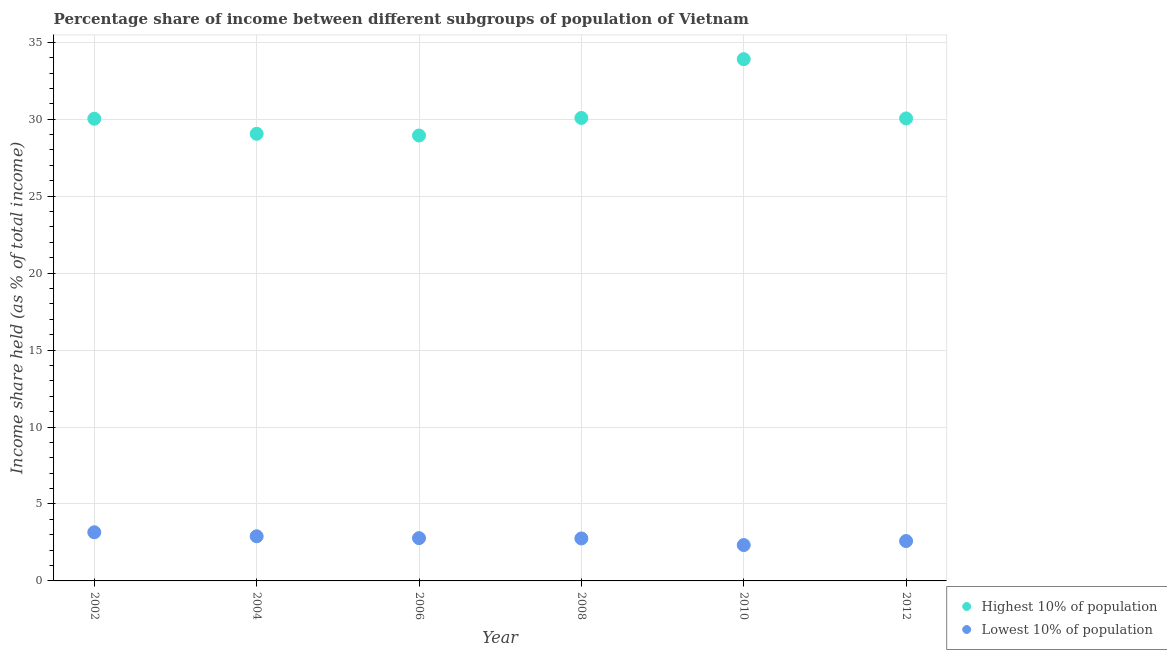How many different coloured dotlines are there?
Offer a very short reply. 2. What is the income share held by highest 10% of the population in 2002?
Give a very brief answer. 30.03. Across all years, what is the maximum income share held by lowest 10% of the population?
Ensure brevity in your answer.  3.16. Across all years, what is the minimum income share held by lowest 10% of the population?
Offer a very short reply. 2.33. In which year was the income share held by highest 10% of the population maximum?
Offer a very short reply. 2010. What is the total income share held by highest 10% of the population in the graph?
Offer a terse response. 182.05. What is the difference between the income share held by lowest 10% of the population in 2004 and that in 2010?
Your answer should be very brief. 0.57. What is the difference between the income share held by highest 10% of the population in 2006 and the income share held by lowest 10% of the population in 2012?
Offer a very short reply. 26.35. What is the average income share held by highest 10% of the population per year?
Provide a short and direct response. 30.34. In the year 2002, what is the difference between the income share held by lowest 10% of the population and income share held by highest 10% of the population?
Offer a terse response. -26.87. What is the ratio of the income share held by lowest 10% of the population in 2006 to that in 2012?
Your answer should be compact. 1.07. Is the income share held by highest 10% of the population in 2008 less than that in 2012?
Your answer should be compact. No. Is the difference between the income share held by lowest 10% of the population in 2002 and 2012 greater than the difference between the income share held by highest 10% of the population in 2002 and 2012?
Your response must be concise. Yes. What is the difference between the highest and the second highest income share held by lowest 10% of the population?
Your answer should be very brief. 0.26. What is the difference between the highest and the lowest income share held by highest 10% of the population?
Provide a short and direct response. 4.96. In how many years, is the income share held by highest 10% of the population greater than the average income share held by highest 10% of the population taken over all years?
Your answer should be very brief. 1. Does the income share held by lowest 10% of the population monotonically increase over the years?
Your answer should be compact. No. How many years are there in the graph?
Provide a short and direct response. 6. Are the values on the major ticks of Y-axis written in scientific E-notation?
Make the answer very short. No. Does the graph contain any zero values?
Provide a short and direct response. No. Does the graph contain grids?
Keep it short and to the point. Yes. How are the legend labels stacked?
Ensure brevity in your answer.  Vertical. What is the title of the graph?
Offer a very short reply. Percentage share of income between different subgroups of population of Vietnam. Does "Forest" appear as one of the legend labels in the graph?
Your response must be concise. No. What is the label or title of the Y-axis?
Provide a succinct answer. Income share held (as % of total income). What is the Income share held (as % of total income) of Highest 10% of population in 2002?
Make the answer very short. 30.03. What is the Income share held (as % of total income) of Lowest 10% of population in 2002?
Give a very brief answer. 3.16. What is the Income share held (as % of total income) in Highest 10% of population in 2004?
Provide a short and direct response. 29.05. What is the Income share held (as % of total income) of Lowest 10% of population in 2004?
Provide a succinct answer. 2.9. What is the Income share held (as % of total income) of Highest 10% of population in 2006?
Ensure brevity in your answer.  28.94. What is the Income share held (as % of total income) of Lowest 10% of population in 2006?
Provide a succinct answer. 2.78. What is the Income share held (as % of total income) in Highest 10% of population in 2008?
Offer a terse response. 30.08. What is the Income share held (as % of total income) of Lowest 10% of population in 2008?
Give a very brief answer. 2.76. What is the Income share held (as % of total income) in Highest 10% of population in 2010?
Provide a short and direct response. 33.9. What is the Income share held (as % of total income) in Lowest 10% of population in 2010?
Your answer should be compact. 2.33. What is the Income share held (as % of total income) of Highest 10% of population in 2012?
Ensure brevity in your answer.  30.05. What is the Income share held (as % of total income) in Lowest 10% of population in 2012?
Offer a terse response. 2.59. Across all years, what is the maximum Income share held (as % of total income) in Highest 10% of population?
Give a very brief answer. 33.9. Across all years, what is the maximum Income share held (as % of total income) in Lowest 10% of population?
Provide a short and direct response. 3.16. Across all years, what is the minimum Income share held (as % of total income) in Highest 10% of population?
Give a very brief answer. 28.94. Across all years, what is the minimum Income share held (as % of total income) of Lowest 10% of population?
Make the answer very short. 2.33. What is the total Income share held (as % of total income) of Highest 10% of population in the graph?
Provide a short and direct response. 182.05. What is the total Income share held (as % of total income) of Lowest 10% of population in the graph?
Give a very brief answer. 16.52. What is the difference between the Income share held (as % of total income) in Lowest 10% of population in 2002 and that in 2004?
Provide a succinct answer. 0.26. What is the difference between the Income share held (as % of total income) in Highest 10% of population in 2002 and that in 2006?
Your answer should be very brief. 1.09. What is the difference between the Income share held (as % of total income) of Lowest 10% of population in 2002 and that in 2006?
Provide a succinct answer. 0.38. What is the difference between the Income share held (as % of total income) of Highest 10% of population in 2002 and that in 2010?
Offer a very short reply. -3.87. What is the difference between the Income share held (as % of total income) of Lowest 10% of population in 2002 and that in 2010?
Your answer should be compact. 0.83. What is the difference between the Income share held (as % of total income) in Highest 10% of population in 2002 and that in 2012?
Ensure brevity in your answer.  -0.02. What is the difference between the Income share held (as % of total income) in Lowest 10% of population in 2002 and that in 2012?
Provide a short and direct response. 0.57. What is the difference between the Income share held (as % of total income) in Highest 10% of population in 2004 and that in 2006?
Offer a terse response. 0.11. What is the difference between the Income share held (as % of total income) in Lowest 10% of population in 2004 and that in 2006?
Offer a very short reply. 0.12. What is the difference between the Income share held (as % of total income) in Highest 10% of population in 2004 and that in 2008?
Your answer should be compact. -1.03. What is the difference between the Income share held (as % of total income) in Lowest 10% of population in 2004 and that in 2008?
Your response must be concise. 0.14. What is the difference between the Income share held (as % of total income) of Highest 10% of population in 2004 and that in 2010?
Your answer should be compact. -4.85. What is the difference between the Income share held (as % of total income) in Lowest 10% of population in 2004 and that in 2010?
Your answer should be very brief. 0.57. What is the difference between the Income share held (as % of total income) in Lowest 10% of population in 2004 and that in 2012?
Give a very brief answer. 0.31. What is the difference between the Income share held (as % of total income) in Highest 10% of population in 2006 and that in 2008?
Your response must be concise. -1.14. What is the difference between the Income share held (as % of total income) in Lowest 10% of population in 2006 and that in 2008?
Make the answer very short. 0.02. What is the difference between the Income share held (as % of total income) in Highest 10% of population in 2006 and that in 2010?
Make the answer very short. -4.96. What is the difference between the Income share held (as % of total income) in Lowest 10% of population in 2006 and that in 2010?
Provide a succinct answer. 0.45. What is the difference between the Income share held (as % of total income) in Highest 10% of population in 2006 and that in 2012?
Provide a short and direct response. -1.11. What is the difference between the Income share held (as % of total income) of Lowest 10% of population in 2006 and that in 2012?
Provide a succinct answer. 0.19. What is the difference between the Income share held (as % of total income) in Highest 10% of population in 2008 and that in 2010?
Give a very brief answer. -3.82. What is the difference between the Income share held (as % of total income) of Lowest 10% of population in 2008 and that in 2010?
Offer a terse response. 0.43. What is the difference between the Income share held (as % of total income) in Highest 10% of population in 2008 and that in 2012?
Your response must be concise. 0.03. What is the difference between the Income share held (as % of total income) of Lowest 10% of population in 2008 and that in 2012?
Your response must be concise. 0.17. What is the difference between the Income share held (as % of total income) of Highest 10% of population in 2010 and that in 2012?
Your answer should be very brief. 3.85. What is the difference between the Income share held (as % of total income) of Lowest 10% of population in 2010 and that in 2012?
Keep it short and to the point. -0.26. What is the difference between the Income share held (as % of total income) in Highest 10% of population in 2002 and the Income share held (as % of total income) in Lowest 10% of population in 2004?
Your answer should be very brief. 27.13. What is the difference between the Income share held (as % of total income) in Highest 10% of population in 2002 and the Income share held (as % of total income) in Lowest 10% of population in 2006?
Your answer should be very brief. 27.25. What is the difference between the Income share held (as % of total income) in Highest 10% of population in 2002 and the Income share held (as % of total income) in Lowest 10% of population in 2008?
Ensure brevity in your answer.  27.27. What is the difference between the Income share held (as % of total income) in Highest 10% of population in 2002 and the Income share held (as % of total income) in Lowest 10% of population in 2010?
Offer a very short reply. 27.7. What is the difference between the Income share held (as % of total income) in Highest 10% of population in 2002 and the Income share held (as % of total income) in Lowest 10% of population in 2012?
Offer a very short reply. 27.44. What is the difference between the Income share held (as % of total income) of Highest 10% of population in 2004 and the Income share held (as % of total income) of Lowest 10% of population in 2006?
Offer a terse response. 26.27. What is the difference between the Income share held (as % of total income) in Highest 10% of population in 2004 and the Income share held (as % of total income) in Lowest 10% of population in 2008?
Ensure brevity in your answer.  26.29. What is the difference between the Income share held (as % of total income) in Highest 10% of population in 2004 and the Income share held (as % of total income) in Lowest 10% of population in 2010?
Give a very brief answer. 26.72. What is the difference between the Income share held (as % of total income) of Highest 10% of population in 2004 and the Income share held (as % of total income) of Lowest 10% of population in 2012?
Your answer should be very brief. 26.46. What is the difference between the Income share held (as % of total income) in Highest 10% of population in 2006 and the Income share held (as % of total income) in Lowest 10% of population in 2008?
Your response must be concise. 26.18. What is the difference between the Income share held (as % of total income) of Highest 10% of population in 2006 and the Income share held (as % of total income) of Lowest 10% of population in 2010?
Offer a very short reply. 26.61. What is the difference between the Income share held (as % of total income) of Highest 10% of population in 2006 and the Income share held (as % of total income) of Lowest 10% of population in 2012?
Ensure brevity in your answer.  26.35. What is the difference between the Income share held (as % of total income) of Highest 10% of population in 2008 and the Income share held (as % of total income) of Lowest 10% of population in 2010?
Give a very brief answer. 27.75. What is the difference between the Income share held (as % of total income) in Highest 10% of population in 2008 and the Income share held (as % of total income) in Lowest 10% of population in 2012?
Ensure brevity in your answer.  27.49. What is the difference between the Income share held (as % of total income) in Highest 10% of population in 2010 and the Income share held (as % of total income) in Lowest 10% of population in 2012?
Your response must be concise. 31.31. What is the average Income share held (as % of total income) of Highest 10% of population per year?
Keep it short and to the point. 30.34. What is the average Income share held (as % of total income) of Lowest 10% of population per year?
Ensure brevity in your answer.  2.75. In the year 2002, what is the difference between the Income share held (as % of total income) in Highest 10% of population and Income share held (as % of total income) in Lowest 10% of population?
Offer a terse response. 26.87. In the year 2004, what is the difference between the Income share held (as % of total income) in Highest 10% of population and Income share held (as % of total income) in Lowest 10% of population?
Offer a very short reply. 26.15. In the year 2006, what is the difference between the Income share held (as % of total income) in Highest 10% of population and Income share held (as % of total income) in Lowest 10% of population?
Give a very brief answer. 26.16. In the year 2008, what is the difference between the Income share held (as % of total income) in Highest 10% of population and Income share held (as % of total income) in Lowest 10% of population?
Ensure brevity in your answer.  27.32. In the year 2010, what is the difference between the Income share held (as % of total income) in Highest 10% of population and Income share held (as % of total income) in Lowest 10% of population?
Give a very brief answer. 31.57. In the year 2012, what is the difference between the Income share held (as % of total income) in Highest 10% of population and Income share held (as % of total income) in Lowest 10% of population?
Provide a short and direct response. 27.46. What is the ratio of the Income share held (as % of total income) in Highest 10% of population in 2002 to that in 2004?
Offer a terse response. 1.03. What is the ratio of the Income share held (as % of total income) in Lowest 10% of population in 2002 to that in 2004?
Keep it short and to the point. 1.09. What is the ratio of the Income share held (as % of total income) in Highest 10% of population in 2002 to that in 2006?
Your answer should be compact. 1.04. What is the ratio of the Income share held (as % of total income) in Lowest 10% of population in 2002 to that in 2006?
Provide a succinct answer. 1.14. What is the ratio of the Income share held (as % of total income) in Lowest 10% of population in 2002 to that in 2008?
Provide a short and direct response. 1.14. What is the ratio of the Income share held (as % of total income) of Highest 10% of population in 2002 to that in 2010?
Ensure brevity in your answer.  0.89. What is the ratio of the Income share held (as % of total income) in Lowest 10% of population in 2002 to that in 2010?
Give a very brief answer. 1.36. What is the ratio of the Income share held (as % of total income) in Highest 10% of population in 2002 to that in 2012?
Offer a very short reply. 1. What is the ratio of the Income share held (as % of total income) of Lowest 10% of population in 2002 to that in 2012?
Give a very brief answer. 1.22. What is the ratio of the Income share held (as % of total income) of Highest 10% of population in 2004 to that in 2006?
Offer a very short reply. 1. What is the ratio of the Income share held (as % of total income) of Lowest 10% of population in 2004 to that in 2006?
Offer a very short reply. 1.04. What is the ratio of the Income share held (as % of total income) in Highest 10% of population in 2004 to that in 2008?
Make the answer very short. 0.97. What is the ratio of the Income share held (as % of total income) in Lowest 10% of population in 2004 to that in 2008?
Provide a short and direct response. 1.05. What is the ratio of the Income share held (as % of total income) in Highest 10% of population in 2004 to that in 2010?
Provide a succinct answer. 0.86. What is the ratio of the Income share held (as % of total income) in Lowest 10% of population in 2004 to that in 2010?
Ensure brevity in your answer.  1.24. What is the ratio of the Income share held (as % of total income) in Highest 10% of population in 2004 to that in 2012?
Your response must be concise. 0.97. What is the ratio of the Income share held (as % of total income) of Lowest 10% of population in 2004 to that in 2012?
Give a very brief answer. 1.12. What is the ratio of the Income share held (as % of total income) in Highest 10% of population in 2006 to that in 2008?
Your answer should be compact. 0.96. What is the ratio of the Income share held (as % of total income) of Lowest 10% of population in 2006 to that in 2008?
Make the answer very short. 1.01. What is the ratio of the Income share held (as % of total income) in Highest 10% of population in 2006 to that in 2010?
Make the answer very short. 0.85. What is the ratio of the Income share held (as % of total income) in Lowest 10% of population in 2006 to that in 2010?
Ensure brevity in your answer.  1.19. What is the ratio of the Income share held (as % of total income) in Highest 10% of population in 2006 to that in 2012?
Give a very brief answer. 0.96. What is the ratio of the Income share held (as % of total income) in Lowest 10% of population in 2006 to that in 2012?
Offer a very short reply. 1.07. What is the ratio of the Income share held (as % of total income) in Highest 10% of population in 2008 to that in 2010?
Your answer should be compact. 0.89. What is the ratio of the Income share held (as % of total income) of Lowest 10% of population in 2008 to that in 2010?
Give a very brief answer. 1.18. What is the ratio of the Income share held (as % of total income) of Highest 10% of population in 2008 to that in 2012?
Provide a succinct answer. 1. What is the ratio of the Income share held (as % of total income) in Lowest 10% of population in 2008 to that in 2012?
Provide a succinct answer. 1.07. What is the ratio of the Income share held (as % of total income) in Highest 10% of population in 2010 to that in 2012?
Offer a terse response. 1.13. What is the ratio of the Income share held (as % of total income) of Lowest 10% of population in 2010 to that in 2012?
Your answer should be compact. 0.9. What is the difference between the highest and the second highest Income share held (as % of total income) in Highest 10% of population?
Provide a succinct answer. 3.82. What is the difference between the highest and the second highest Income share held (as % of total income) in Lowest 10% of population?
Your response must be concise. 0.26. What is the difference between the highest and the lowest Income share held (as % of total income) in Highest 10% of population?
Offer a terse response. 4.96. What is the difference between the highest and the lowest Income share held (as % of total income) in Lowest 10% of population?
Ensure brevity in your answer.  0.83. 